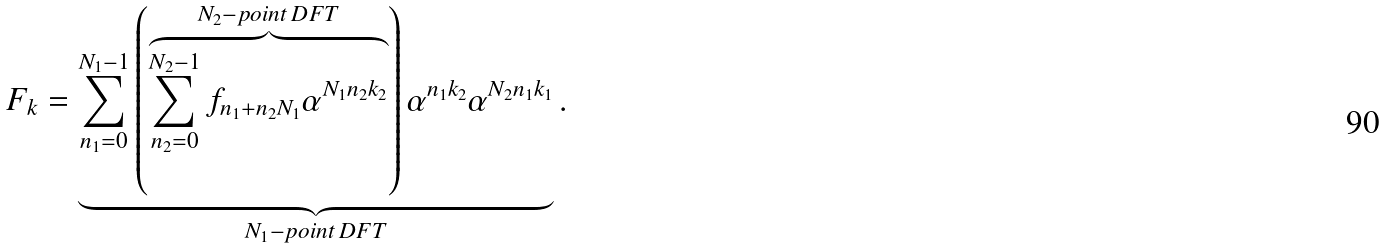<formula> <loc_0><loc_0><loc_500><loc_500>F _ { k } = \underbrace { \sum _ { n _ { 1 } = 0 } ^ { N _ { 1 } - 1 } \left ( \overbrace { \sum _ { n _ { 2 } = 0 } ^ { N _ { 2 } - 1 } f _ { n _ { 1 } + n _ { 2 } N _ { 1 } } \alpha ^ { N _ { 1 } n _ { 2 } k _ { 2 } } } ^ { N _ { 2 } - p o i n t \, D F T } \right ) \alpha ^ { n _ { 1 } k _ { 2 } } \alpha ^ { N _ { 2 } n _ { 1 } k _ { 1 } } } _ { N _ { 1 } - p o i n t \, D F T } .</formula> 